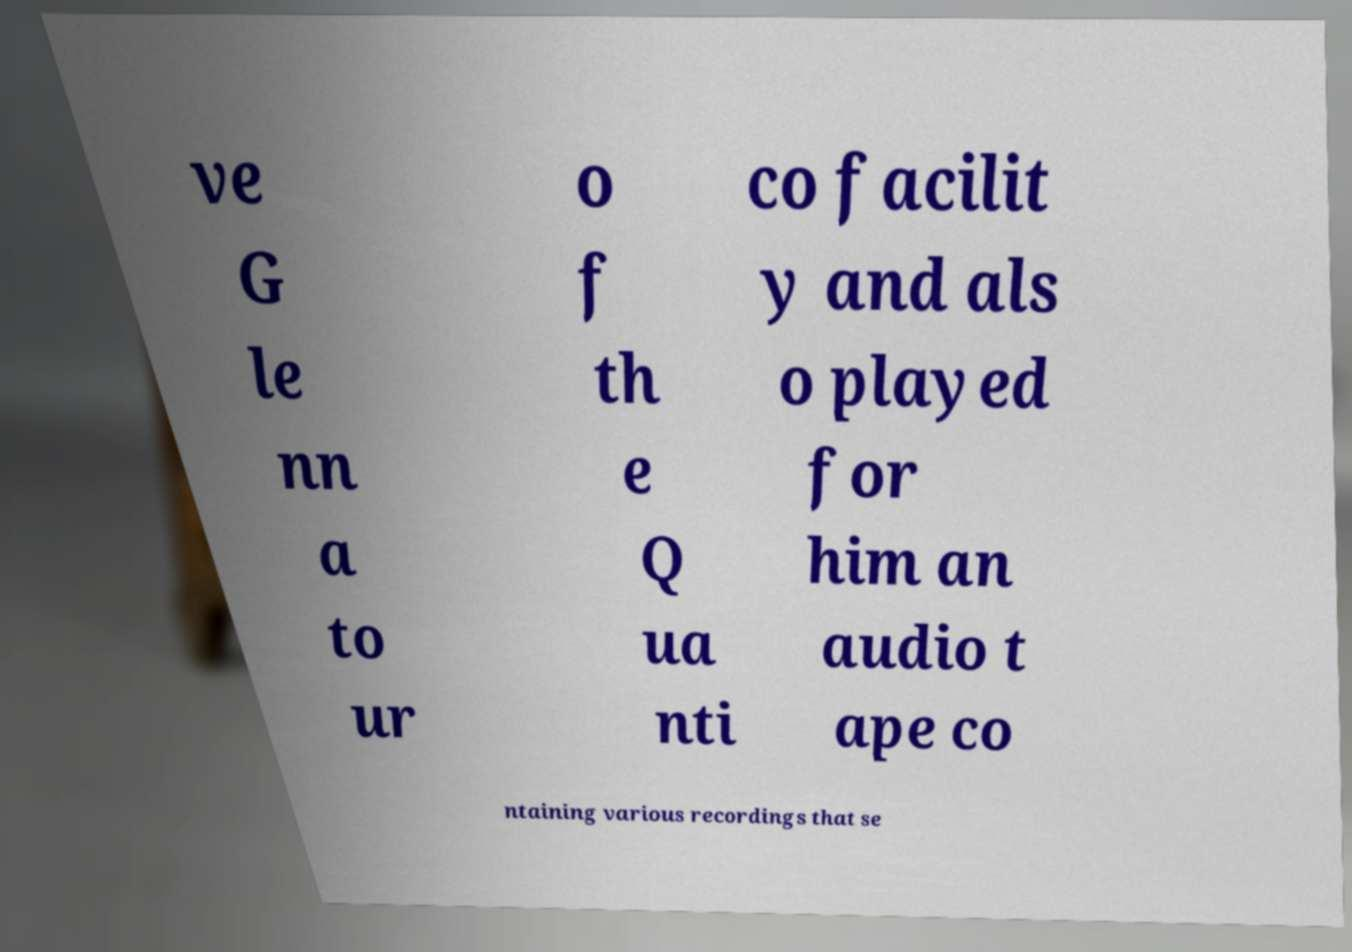What messages or text are displayed in this image? I need them in a readable, typed format. ve G le nn a to ur o f th e Q ua nti co facilit y and als o played for him an audio t ape co ntaining various recordings that se 